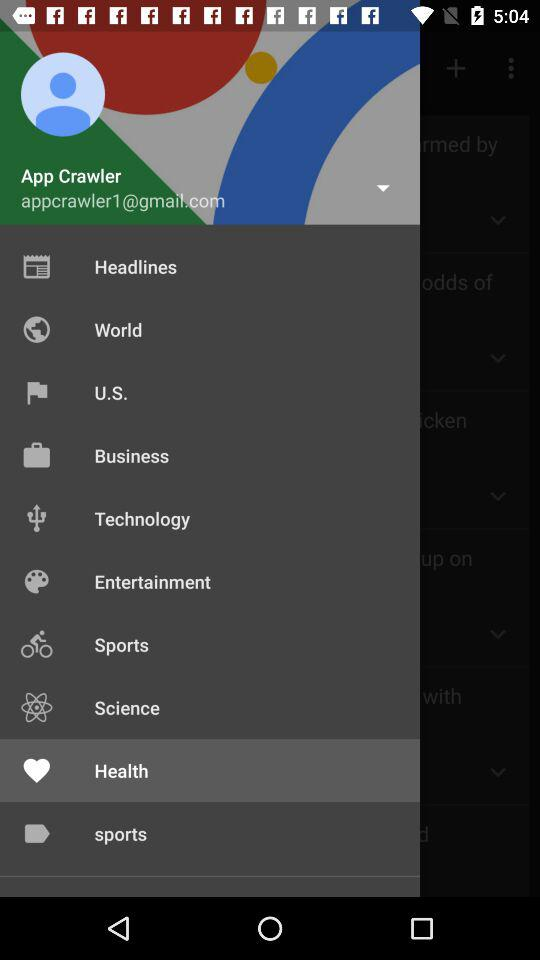What's the selected menu option? The selected menu option is "Health". 